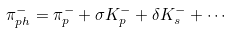Convert formula to latex. <formula><loc_0><loc_0><loc_500><loc_500>\pi ^ { - } _ { p h } = \pi ^ { - } _ { p } + \sigma K ^ { - } _ { p } + \delta K ^ { - } _ { s } + \cdots</formula> 